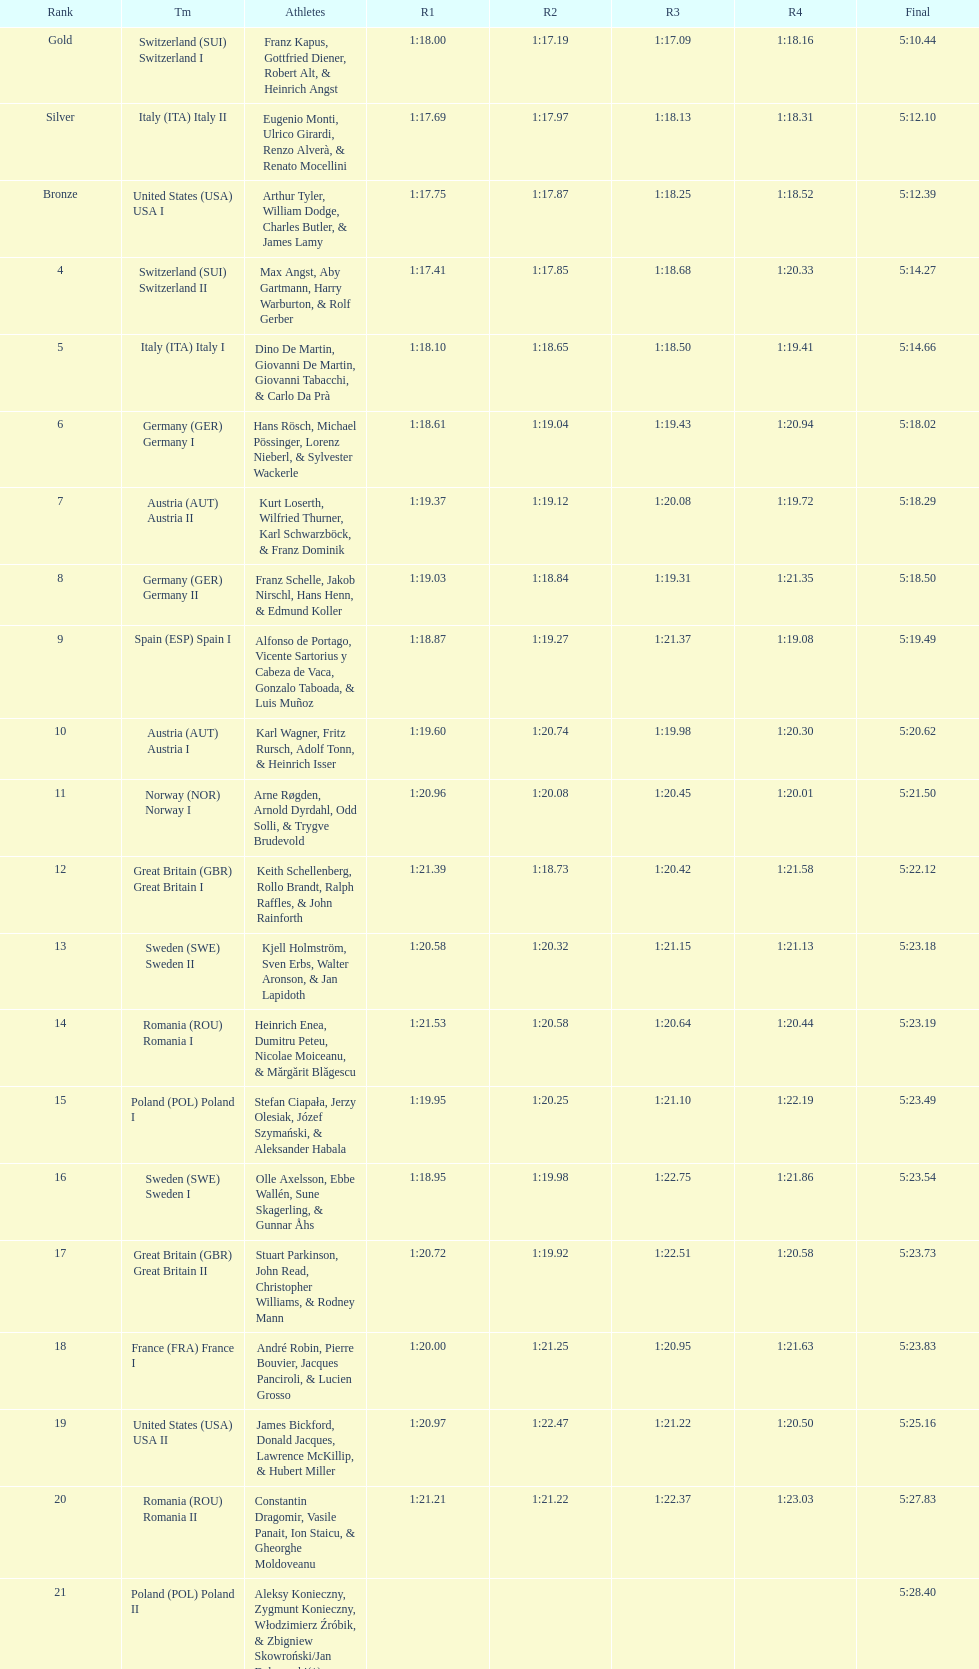Parse the table in full. {'header': ['Rank', 'Tm', 'Athletes', 'R1', 'R2', 'R3', 'R4', 'Final'], 'rows': [['Gold', 'Switzerland\xa0(SUI) Switzerland I', 'Franz Kapus, Gottfried Diener, Robert Alt, & Heinrich Angst', '1:18.00', '1:17.19', '1:17.09', '1:18.16', '5:10.44'], ['Silver', 'Italy\xa0(ITA) Italy II', 'Eugenio Monti, Ulrico Girardi, Renzo Alverà, & Renato Mocellini', '1:17.69', '1:17.97', '1:18.13', '1:18.31', '5:12.10'], ['Bronze', 'United States\xa0(USA) USA I', 'Arthur Tyler, William Dodge, Charles Butler, & James Lamy', '1:17.75', '1:17.87', '1:18.25', '1:18.52', '5:12.39'], ['4', 'Switzerland\xa0(SUI) Switzerland II', 'Max Angst, Aby Gartmann, Harry Warburton, & Rolf Gerber', '1:17.41', '1:17.85', '1:18.68', '1:20.33', '5:14.27'], ['5', 'Italy\xa0(ITA) Italy I', 'Dino De Martin, Giovanni De Martin, Giovanni Tabacchi, & Carlo Da Prà', '1:18.10', '1:18.65', '1:18.50', '1:19.41', '5:14.66'], ['6', 'Germany\xa0(GER) Germany I', 'Hans Rösch, Michael Pössinger, Lorenz Nieberl, & Sylvester Wackerle', '1:18.61', '1:19.04', '1:19.43', '1:20.94', '5:18.02'], ['7', 'Austria\xa0(AUT) Austria II', 'Kurt Loserth, Wilfried Thurner, Karl Schwarzböck, & Franz Dominik', '1:19.37', '1:19.12', '1:20.08', '1:19.72', '5:18.29'], ['8', 'Germany\xa0(GER) Germany II', 'Franz Schelle, Jakob Nirschl, Hans Henn, & Edmund Koller', '1:19.03', '1:18.84', '1:19.31', '1:21.35', '5:18.50'], ['9', 'Spain\xa0(ESP) Spain I', 'Alfonso de Portago, Vicente Sartorius y Cabeza de Vaca, Gonzalo Taboada, & Luis Muñoz', '1:18.87', '1:19.27', '1:21.37', '1:19.08', '5:19.49'], ['10', 'Austria\xa0(AUT) Austria I', 'Karl Wagner, Fritz Rursch, Adolf Tonn, & Heinrich Isser', '1:19.60', '1:20.74', '1:19.98', '1:20.30', '5:20.62'], ['11', 'Norway\xa0(NOR) Norway I', 'Arne Røgden, Arnold Dyrdahl, Odd Solli, & Trygve Brudevold', '1:20.96', '1:20.08', '1:20.45', '1:20.01', '5:21.50'], ['12', 'Great Britain\xa0(GBR) Great Britain I', 'Keith Schellenberg, Rollo Brandt, Ralph Raffles, & John Rainforth', '1:21.39', '1:18.73', '1:20.42', '1:21.58', '5:22.12'], ['13', 'Sweden\xa0(SWE) Sweden II', 'Kjell Holmström, Sven Erbs, Walter Aronson, & Jan Lapidoth', '1:20.58', '1:20.32', '1:21.15', '1:21.13', '5:23.18'], ['14', 'Romania\xa0(ROU) Romania I', 'Heinrich Enea, Dumitru Peteu, Nicolae Moiceanu, & Mărgărit Blăgescu', '1:21.53', '1:20.58', '1:20.64', '1:20.44', '5:23.19'], ['15', 'Poland\xa0(POL) Poland I', 'Stefan Ciapała, Jerzy Olesiak, Józef Szymański, & Aleksander Habala', '1:19.95', '1:20.25', '1:21.10', '1:22.19', '5:23.49'], ['16', 'Sweden\xa0(SWE) Sweden I', 'Olle Axelsson, Ebbe Wallén, Sune Skagerling, & Gunnar Åhs', '1:18.95', '1:19.98', '1:22.75', '1:21.86', '5:23.54'], ['17', 'Great Britain\xa0(GBR) Great Britain II', 'Stuart Parkinson, John Read, Christopher Williams, & Rodney Mann', '1:20.72', '1:19.92', '1:22.51', '1:20.58', '5:23.73'], ['18', 'France\xa0(FRA) France I', 'André Robin, Pierre Bouvier, Jacques Panciroli, & Lucien Grosso', '1:20.00', '1:21.25', '1:20.95', '1:21.63', '5:23.83'], ['19', 'United States\xa0(USA) USA II', 'James Bickford, Donald Jacques, Lawrence McKillip, & Hubert Miller', '1:20.97', '1:22.47', '1:21.22', '1:20.50', '5:25.16'], ['20', 'Romania\xa0(ROU) Romania II', 'Constantin Dragomir, Vasile Panait, Ion Staicu, & Gheorghe Moldoveanu', '1:21.21', '1:21.22', '1:22.37', '1:23.03', '5:27.83'], ['21', 'Poland\xa0(POL) Poland II', 'Aleksy Konieczny, Zygmunt Konieczny, Włodzimierz Źróbik, & Zbigniew Skowroński/Jan Dąbrowski(*)', '', '', '', '', '5:28.40']]} What team came out on top? Switzerland. 